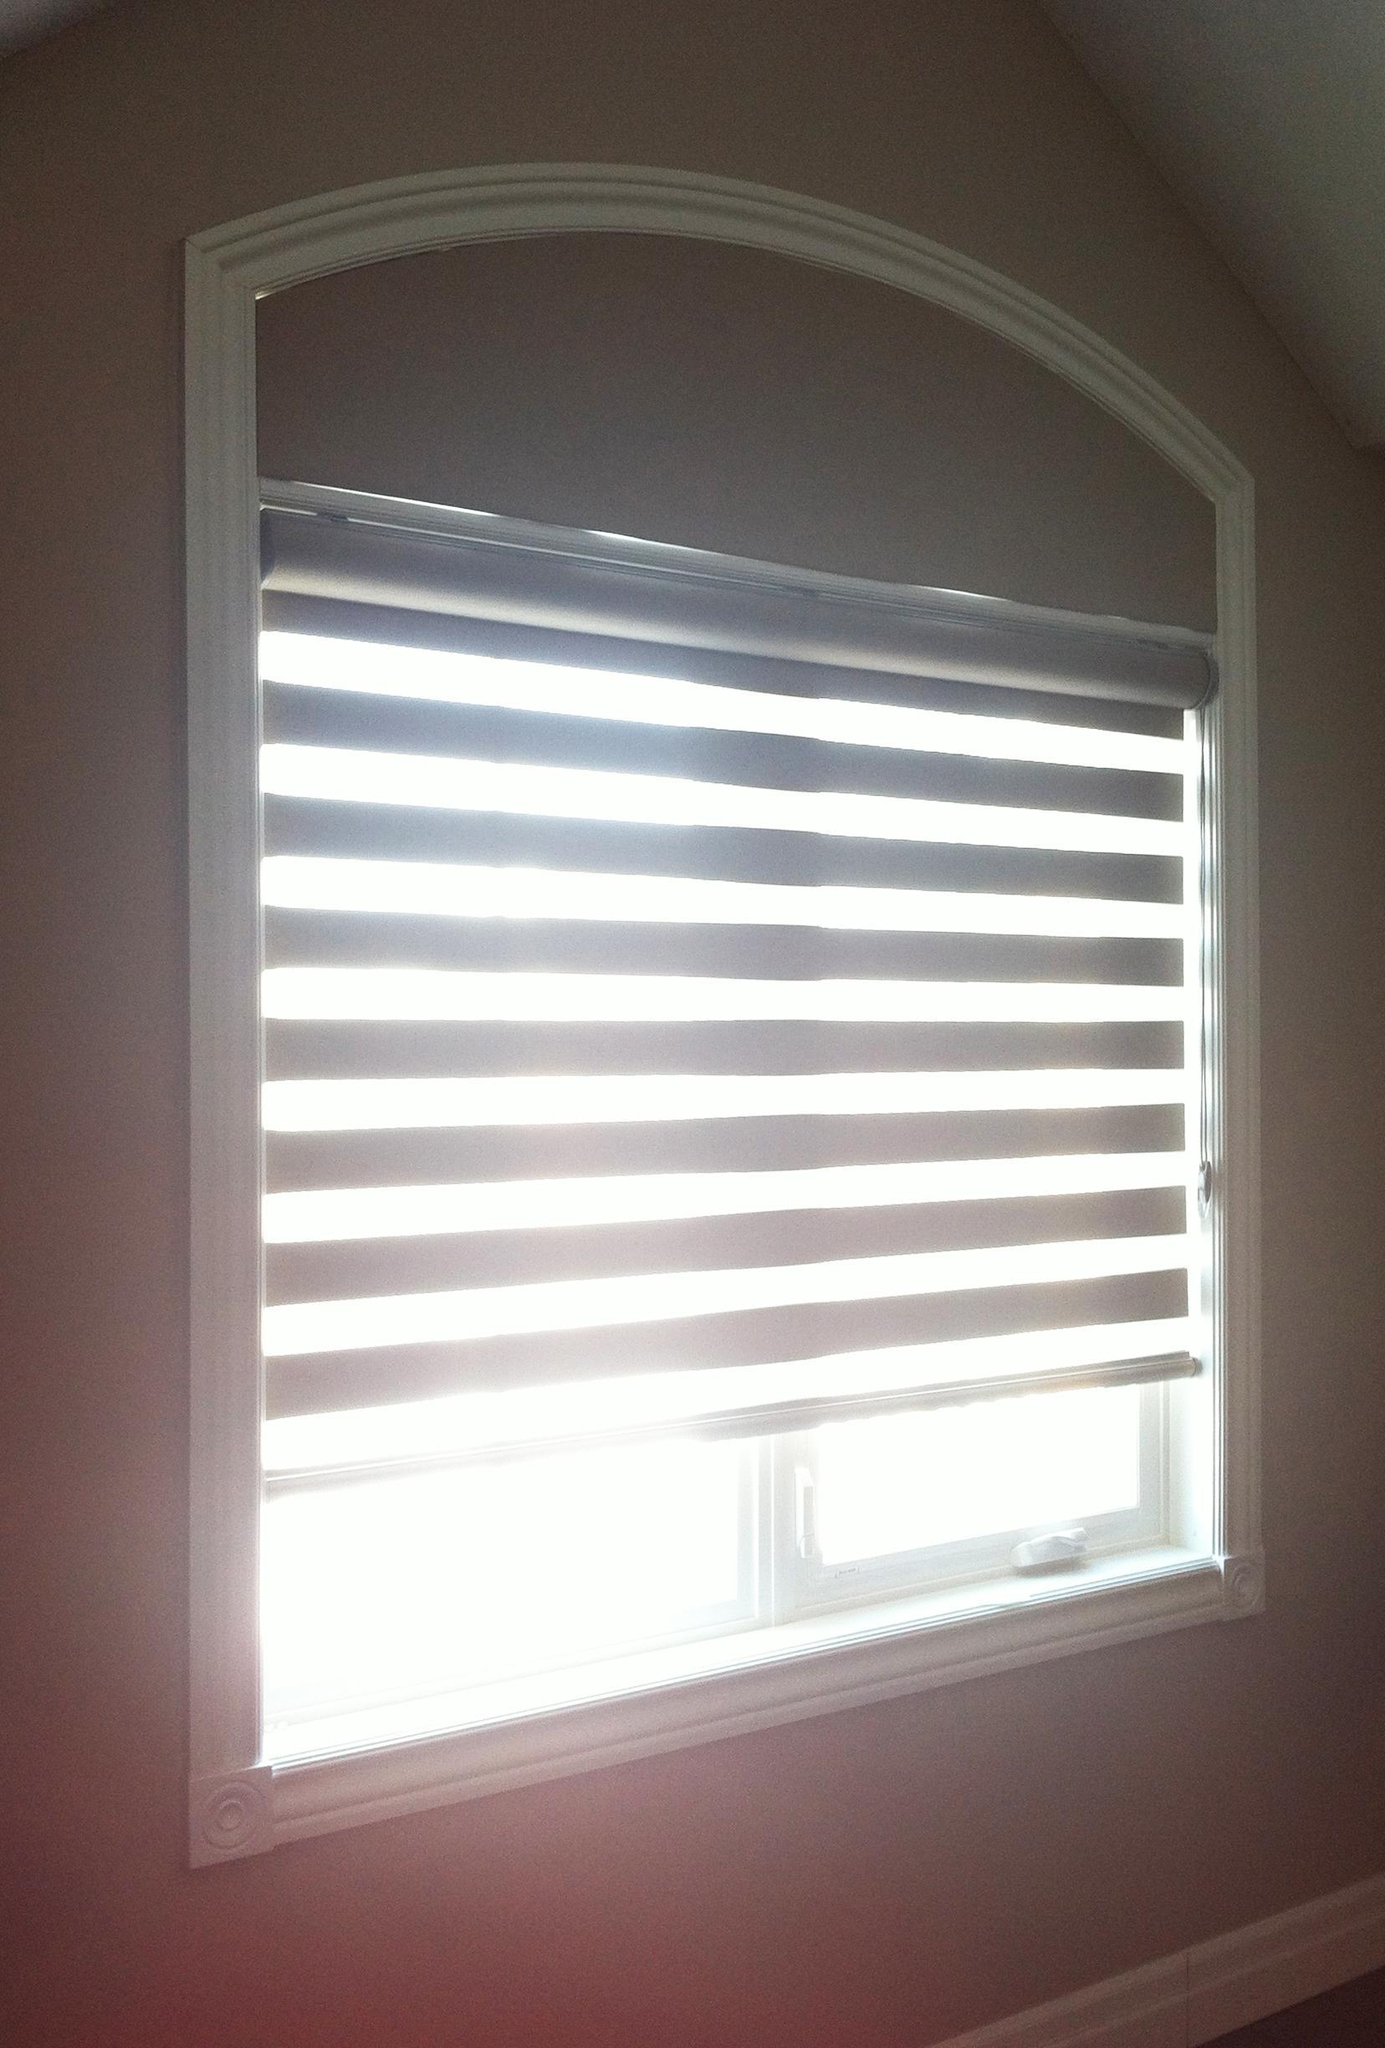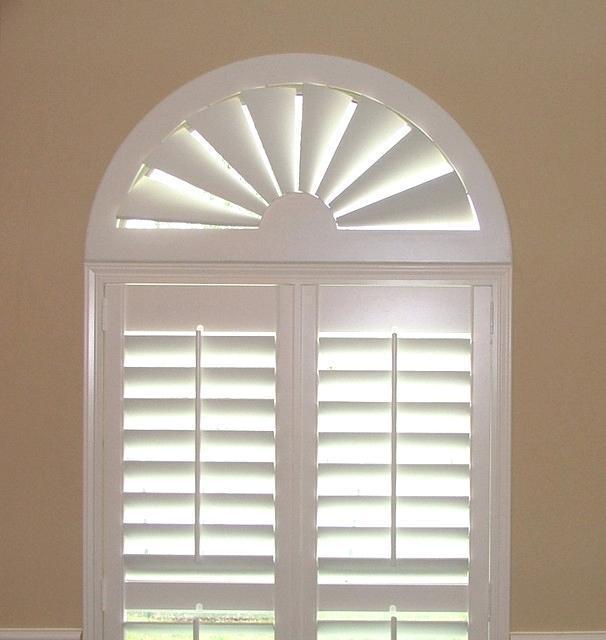The first image is the image on the left, the second image is the image on the right. For the images shown, is this caption "There are only two windows visible." true? Answer yes or no. Yes. The first image is the image on the left, the second image is the image on the right. Analyze the images presented: Is the assertion "There is furniture visible in exactly one image." valid? Answer yes or no. No. 